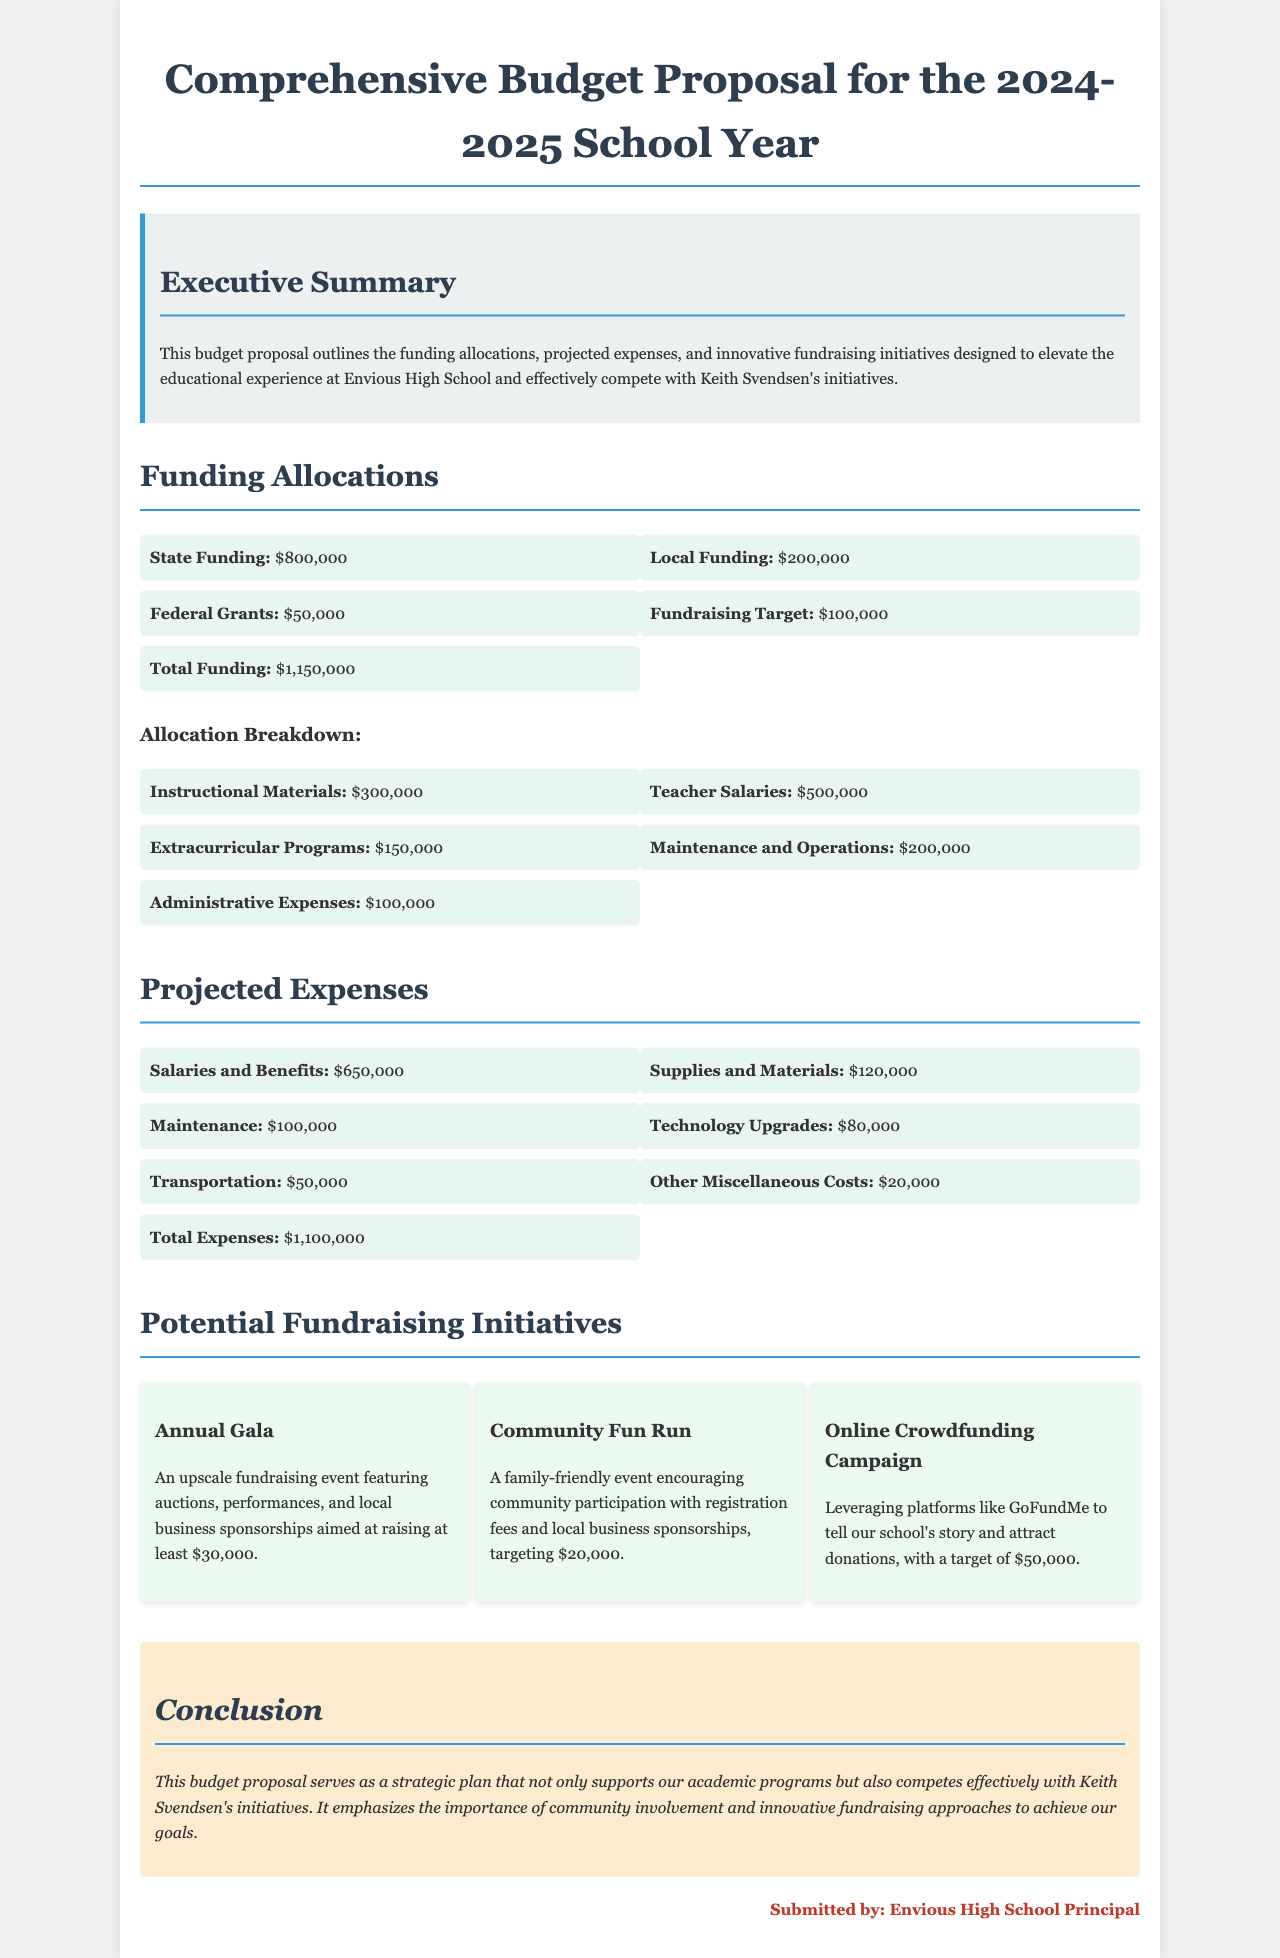What is the total funding? The total funding is provided in the section detailing funding allocations, which sums up to $1,150,000.
Answer: $1,150,000 What is the amount allocated for teacher salaries? Teacher salaries are specified in the allocation breakdown, amounting to $500,000.
Answer: $500,000 How much does the annual gala aim to raise? The document states that the annual gala targets at least $30,000 in fundraising.
Answer: $30,000 What are the total projected expenses? The total projected expenses are outlined in the projected expenses section, totaling $1,100,000.
Answer: $1,100,000 What is the funding from federal grants? The federal grants funding is explicitly mentioned in the funding allocations as $50,000.
Answer: $50,000 Which initiative targets the highest fundraising amount? The online crowdfunding campaign has a target amount of $50,000, making it the highest potential initiative.
Answer: Online Crowdfunding Campaign What is the budget proposal's purpose? The executive summary states that the purpose is to elevate the educational experience and compete with Keith Svendsen's initiatives.
Answer: Compete with Keith Svendsen's initiatives How much is allocated for maintenance and operations? The amount allocated for maintenance and operations is mentioned as $200,000 in the allocation breakdown.
Answer: $200,000 What type of event is the Community Fun Run? The Community Fun Run is described as a family-friendly event aimed at encouraging community participation.
Answer: Family-friendly event 